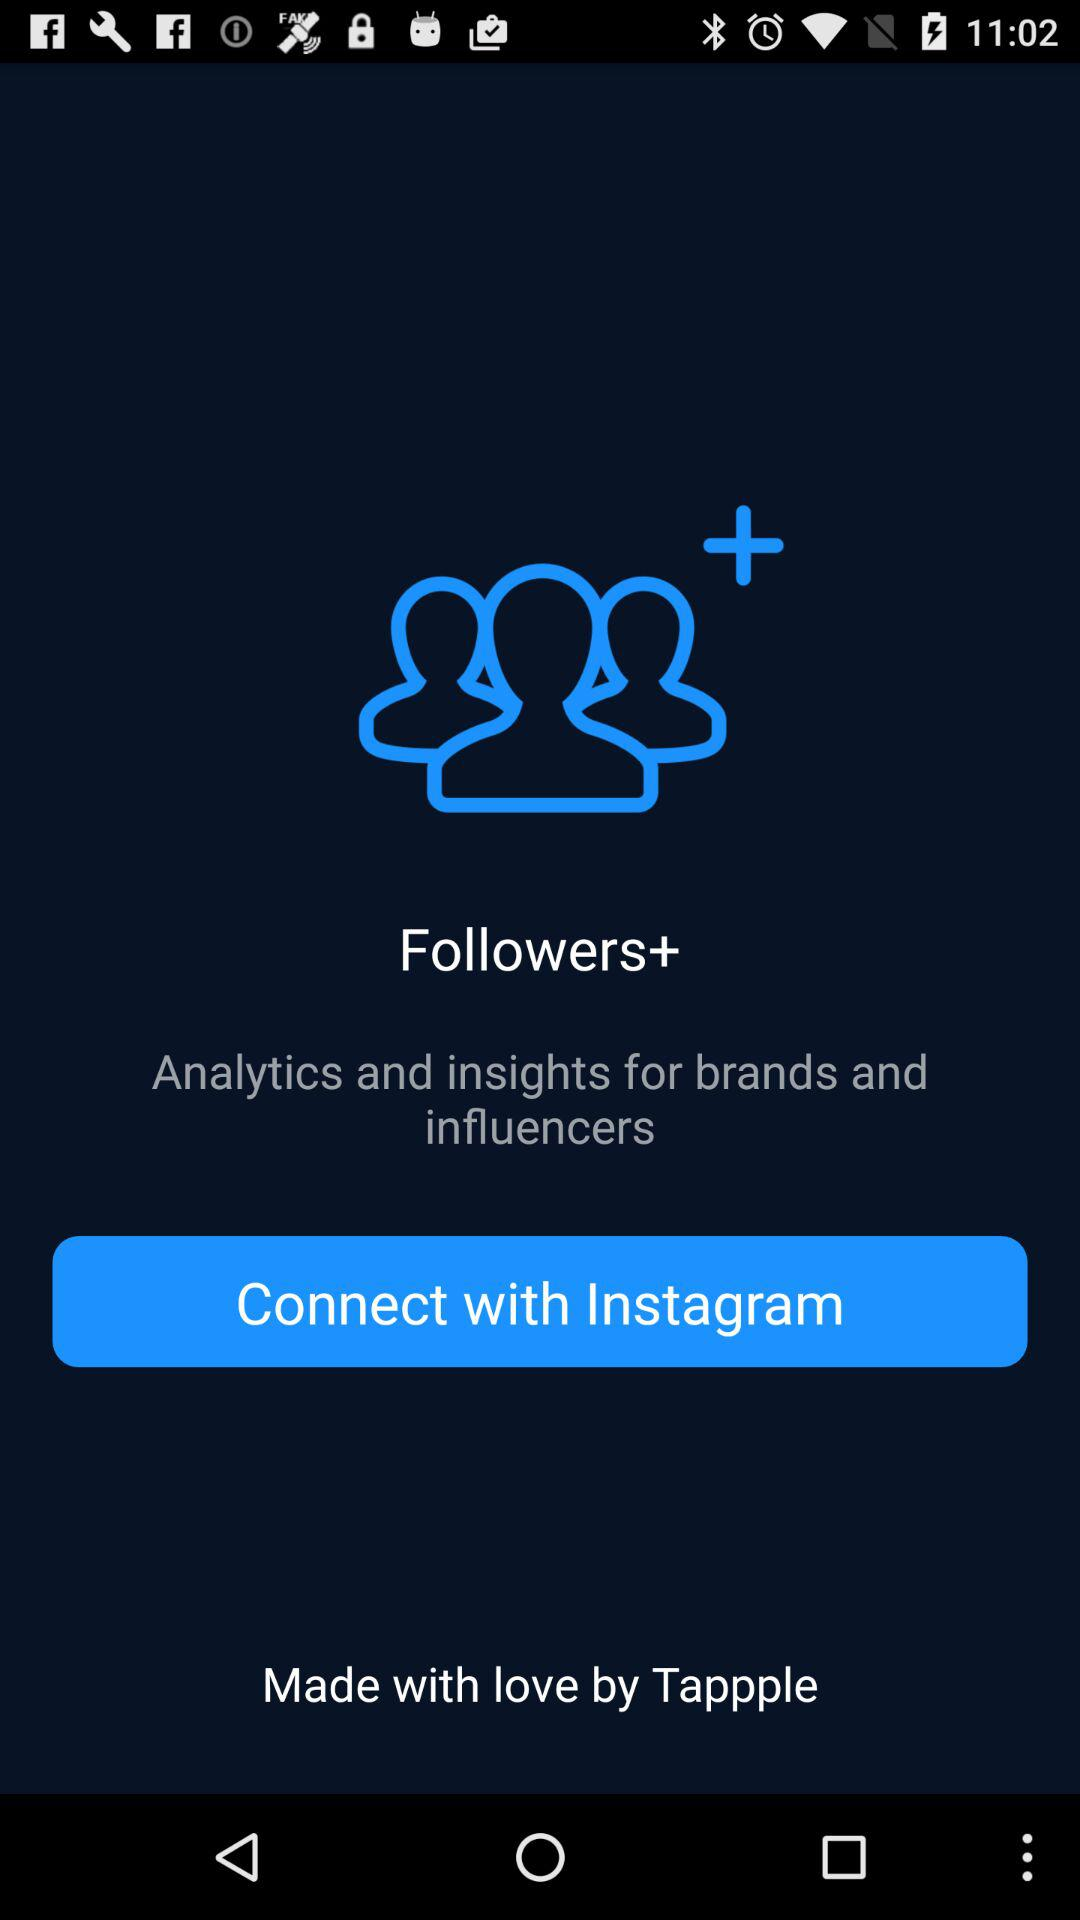What is the app name? The app name is "Followers+". 